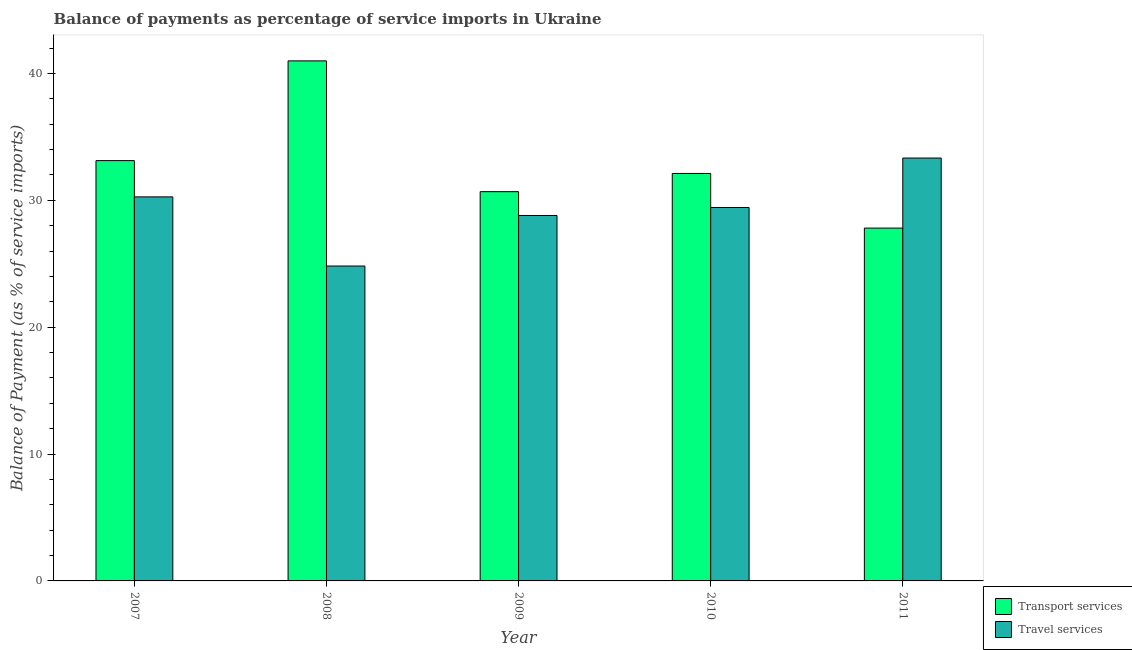How many different coloured bars are there?
Your answer should be very brief. 2. Are the number of bars on each tick of the X-axis equal?
Provide a short and direct response. Yes. How many bars are there on the 5th tick from the left?
Offer a terse response. 2. What is the balance of payments of travel services in 2008?
Your answer should be compact. 24.82. Across all years, what is the maximum balance of payments of travel services?
Keep it short and to the point. 33.33. Across all years, what is the minimum balance of payments of travel services?
Offer a terse response. 24.82. In which year was the balance of payments of travel services maximum?
Your answer should be compact. 2011. What is the total balance of payments of transport services in the graph?
Provide a short and direct response. 164.74. What is the difference between the balance of payments of travel services in 2008 and that in 2010?
Offer a terse response. -4.62. What is the difference between the balance of payments of travel services in 2010 and the balance of payments of transport services in 2007?
Ensure brevity in your answer.  -0.83. What is the average balance of payments of travel services per year?
Provide a succinct answer. 29.33. What is the ratio of the balance of payments of travel services in 2008 to that in 2010?
Offer a very short reply. 0.84. Is the difference between the balance of payments of travel services in 2008 and 2011 greater than the difference between the balance of payments of transport services in 2008 and 2011?
Your answer should be compact. No. What is the difference between the highest and the second highest balance of payments of transport services?
Your answer should be very brief. 7.86. What is the difference between the highest and the lowest balance of payments of travel services?
Your answer should be very brief. 8.51. What does the 1st bar from the left in 2011 represents?
Ensure brevity in your answer.  Transport services. What does the 2nd bar from the right in 2008 represents?
Your answer should be compact. Transport services. How many bars are there?
Provide a short and direct response. 10. How many years are there in the graph?
Your answer should be compact. 5. What is the difference between two consecutive major ticks on the Y-axis?
Make the answer very short. 10. Are the values on the major ticks of Y-axis written in scientific E-notation?
Your answer should be very brief. No. How many legend labels are there?
Your answer should be very brief. 2. How are the legend labels stacked?
Provide a short and direct response. Vertical. What is the title of the graph?
Your response must be concise. Balance of payments as percentage of service imports in Ukraine. Does "Number of arrivals" appear as one of the legend labels in the graph?
Offer a terse response. No. What is the label or title of the X-axis?
Offer a terse response. Year. What is the label or title of the Y-axis?
Make the answer very short. Balance of Payment (as % of service imports). What is the Balance of Payment (as % of service imports) of Transport services in 2007?
Provide a short and direct response. 33.13. What is the Balance of Payment (as % of service imports) of Travel services in 2007?
Make the answer very short. 30.27. What is the Balance of Payment (as % of service imports) of Transport services in 2008?
Provide a short and direct response. 40.99. What is the Balance of Payment (as % of service imports) of Travel services in 2008?
Offer a very short reply. 24.82. What is the Balance of Payment (as % of service imports) of Transport services in 2009?
Ensure brevity in your answer.  30.68. What is the Balance of Payment (as % of service imports) of Travel services in 2009?
Your answer should be very brief. 28.81. What is the Balance of Payment (as % of service imports) of Transport services in 2010?
Your response must be concise. 32.12. What is the Balance of Payment (as % of service imports) of Travel services in 2010?
Your answer should be compact. 29.44. What is the Balance of Payment (as % of service imports) in Transport services in 2011?
Your answer should be compact. 27.81. What is the Balance of Payment (as % of service imports) of Travel services in 2011?
Your answer should be very brief. 33.33. Across all years, what is the maximum Balance of Payment (as % of service imports) in Transport services?
Your response must be concise. 40.99. Across all years, what is the maximum Balance of Payment (as % of service imports) of Travel services?
Provide a succinct answer. 33.33. Across all years, what is the minimum Balance of Payment (as % of service imports) in Transport services?
Give a very brief answer. 27.81. Across all years, what is the minimum Balance of Payment (as % of service imports) in Travel services?
Your answer should be compact. 24.82. What is the total Balance of Payment (as % of service imports) of Transport services in the graph?
Provide a succinct answer. 164.74. What is the total Balance of Payment (as % of service imports) in Travel services in the graph?
Provide a short and direct response. 146.67. What is the difference between the Balance of Payment (as % of service imports) of Transport services in 2007 and that in 2008?
Your answer should be compact. -7.86. What is the difference between the Balance of Payment (as % of service imports) in Travel services in 2007 and that in 2008?
Your answer should be compact. 5.45. What is the difference between the Balance of Payment (as % of service imports) in Transport services in 2007 and that in 2009?
Ensure brevity in your answer.  2.45. What is the difference between the Balance of Payment (as % of service imports) in Travel services in 2007 and that in 2009?
Your response must be concise. 1.47. What is the difference between the Balance of Payment (as % of service imports) in Transport services in 2007 and that in 2010?
Give a very brief answer. 1.01. What is the difference between the Balance of Payment (as % of service imports) in Travel services in 2007 and that in 2010?
Your answer should be very brief. 0.83. What is the difference between the Balance of Payment (as % of service imports) of Transport services in 2007 and that in 2011?
Ensure brevity in your answer.  5.32. What is the difference between the Balance of Payment (as % of service imports) in Travel services in 2007 and that in 2011?
Your answer should be compact. -3.06. What is the difference between the Balance of Payment (as % of service imports) of Transport services in 2008 and that in 2009?
Keep it short and to the point. 10.31. What is the difference between the Balance of Payment (as % of service imports) of Travel services in 2008 and that in 2009?
Your answer should be very brief. -3.99. What is the difference between the Balance of Payment (as % of service imports) of Transport services in 2008 and that in 2010?
Provide a succinct answer. 8.87. What is the difference between the Balance of Payment (as % of service imports) in Travel services in 2008 and that in 2010?
Offer a very short reply. -4.62. What is the difference between the Balance of Payment (as % of service imports) of Transport services in 2008 and that in 2011?
Provide a succinct answer. 13.18. What is the difference between the Balance of Payment (as % of service imports) of Travel services in 2008 and that in 2011?
Your response must be concise. -8.51. What is the difference between the Balance of Payment (as % of service imports) in Transport services in 2009 and that in 2010?
Provide a succinct answer. -1.44. What is the difference between the Balance of Payment (as % of service imports) in Travel services in 2009 and that in 2010?
Ensure brevity in your answer.  -0.63. What is the difference between the Balance of Payment (as % of service imports) in Transport services in 2009 and that in 2011?
Your answer should be very brief. 2.87. What is the difference between the Balance of Payment (as % of service imports) in Travel services in 2009 and that in 2011?
Ensure brevity in your answer.  -4.53. What is the difference between the Balance of Payment (as % of service imports) of Transport services in 2010 and that in 2011?
Ensure brevity in your answer.  4.31. What is the difference between the Balance of Payment (as % of service imports) of Travel services in 2010 and that in 2011?
Offer a terse response. -3.9. What is the difference between the Balance of Payment (as % of service imports) of Transport services in 2007 and the Balance of Payment (as % of service imports) of Travel services in 2008?
Offer a very short reply. 8.31. What is the difference between the Balance of Payment (as % of service imports) in Transport services in 2007 and the Balance of Payment (as % of service imports) in Travel services in 2009?
Give a very brief answer. 4.32. What is the difference between the Balance of Payment (as % of service imports) of Transport services in 2007 and the Balance of Payment (as % of service imports) of Travel services in 2010?
Provide a short and direct response. 3.69. What is the difference between the Balance of Payment (as % of service imports) in Transport services in 2007 and the Balance of Payment (as % of service imports) in Travel services in 2011?
Your response must be concise. -0.2. What is the difference between the Balance of Payment (as % of service imports) of Transport services in 2008 and the Balance of Payment (as % of service imports) of Travel services in 2009?
Your response must be concise. 12.19. What is the difference between the Balance of Payment (as % of service imports) of Transport services in 2008 and the Balance of Payment (as % of service imports) of Travel services in 2010?
Make the answer very short. 11.56. What is the difference between the Balance of Payment (as % of service imports) in Transport services in 2008 and the Balance of Payment (as % of service imports) in Travel services in 2011?
Provide a succinct answer. 7.66. What is the difference between the Balance of Payment (as % of service imports) of Transport services in 2009 and the Balance of Payment (as % of service imports) of Travel services in 2010?
Provide a short and direct response. 1.25. What is the difference between the Balance of Payment (as % of service imports) of Transport services in 2009 and the Balance of Payment (as % of service imports) of Travel services in 2011?
Offer a very short reply. -2.65. What is the difference between the Balance of Payment (as % of service imports) of Transport services in 2010 and the Balance of Payment (as % of service imports) of Travel services in 2011?
Offer a very short reply. -1.21. What is the average Balance of Payment (as % of service imports) of Transport services per year?
Offer a terse response. 32.95. What is the average Balance of Payment (as % of service imports) of Travel services per year?
Keep it short and to the point. 29.33. In the year 2007, what is the difference between the Balance of Payment (as % of service imports) in Transport services and Balance of Payment (as % of service imports) in Travel services?
Provide a succinct answer. 2.86. In the year 2008, what is the difference between the Balance of Payment (as % of service imports) of Transport services and Balance of Payment (as % of service imports) of Travel services?
Your response must be concise. 16.17. In the year 2009, what is the difference between the Balance of Payment (as % of service imports) of Transport services and Balance of Payment (as % of service imports) of Travel services?
Make the answer very short. 1.88. In the year 2010, what is the difference between the Balance of Payment (as % of service imports) in Transport services and Balance of Payment (as % of service imports) in Travel services?
Ensure brevity in your answer.  2.68. In the year 2011, what is the difference between the Balance of Payment (as % of service imports) in Transport services and Balance of Payment (as % of service imports) in Travel services?
Give a very brief answer. -5.52. What is the ratio of the Balance of Payment (as % of service imports) of Transport services in 2007 to that in 2008?
Provide a short and direct response. 0.81. What is the ratio of the Balance of Payment (as % of service imports) in Travel services in 2007 to that in 2008?
Give a very brief answer. 1.22. What is the ratio of the Balance of Payment (as % of service imports) of Transport services in 2007 to that in 2009?
Provide a succinct answer. 1.08. What is the ratio of the Balance of Payment (as % of service imports) in Travel services in 2007 to that in 2009?
Make the answer very short. 1.05. What is the ratio of the Balance of Payment (as % of service imports) in Transport services in 2007 to that in 2010?
Your answer should be very brief. 1.03. What is the ratio of the Balance of Payment (as % of service imports) of Travel services in 2007 to that in 2010?
Give a very brief answer. 1.03. What is the ratio of the Balance of Payment (as % of service imports) of Transport services in 2007 to that in 2011?
Provide a succinct answer. 1.19. What is the ratio of the Balance of Payment (as % of service imports) of Travel services in 2007 to that in 2011?
Keep it short and to the point. 0.91. What is the ratio of the Balance of Payment (as % of service imports) of Transport services in 2008 to that in 2009?
Offer a terse response. 1.34. What is the ratio of the Balance of Payment (as % of service imports) of Travel services in 2008 to that in 2009?
Your answer should be very brief. 0.86. What is the ratio of the Balance of Payment (as % of service imports) in Transport services in 2008 to that in 2010?
Keep it short and to the point. 1.28. What is the ratio of the Balance of Payment (as % of service imports) of Travel services in 2008 to that in 2010?
Your response must be concise. 0.84. What is the ratio of the Balance of Payment (as % of service imports) of Transport services in 2008 to that in 2011?
Your answer should be compact. 1.47. What is the ratio of the Balance of Payment (as % of service imports) of Travel services in 2008 to that in 2011?
Offer a terse response. 0.74. What is the ratio of the Balance of Payment (as % of service imports) of Transport services in 2009 to that in 2010?
Offer a terse response. 0.96. What is the ratio of the Balance of Payment (as % of service imports) in Travel services in 2009 to that in 2010?
Your response must be concise. 0.98. What is the ratio of the Balance of Payment (as % of service imports) of Transport services in 2009 to that in 2011?
Make the answer very short. 1.1. What is the ratio of the Balance of Payment (as % of service imports) of Travel services in 2009 to that in 2011?
Offer a terse response. 0.86. What is the ratio of the Balance of Payment (as % of service imports) in Transport services in 2010 to that in 2011?
Your answer should be very brief. 1.15. What is the ratio of the Balance of Payment (as % of service imports) of Travel services in 2010 to that in 2011?
Ensure brevity in your answer.  0.88. What is the difference between the highest and the second highest Balance of Payment (as % of service imports) of Transport services?
Provide a short and direct response. 7.86. What is the difference between the highest and the second highest Balance of Payment (as % of service imports) of Travel services?
Keep it short and to the point. 3.06. What is the difference between the highest and the lowest Balance of Payment (as % of service imports) in Transport services?
Your answer should be compact. 13.18. What is the difference between the highest and the lowest Balance of Payment (as % of service imports) of Travel services?
Give a very brief answer. 8.51. 